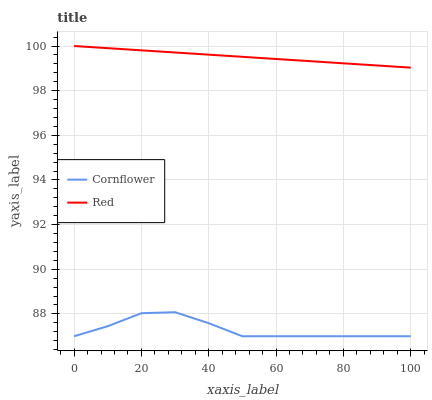Does Cornflower have the minimum area under the curve?
Answer yes or no. Yes. Does Red have the maximum area under the curve?
Answer yes or no. Yes. Does Red have the minimum area under the curve?
Answer yes or no. No. Is Red the smoothest?
Answer yes or no. Yes. Is Cornflower the roughest?
Answer yes or no. Yes. Is Red the roughest?
Answer yes or no. No. Does Cornflower have the lowest value?
Answer yes or no. Yes. Does Red have the lowest value?
Answer yes or no. No. Does Red have the highest value?
Answer yes or no. Yes. Is Cornflower less than Red?
Answer yes or no. Yes. Is Red greater than Cornflower?
Answer yes or no. Yes. Does Cornflower intersect Red?
Answer yes or no. No. 